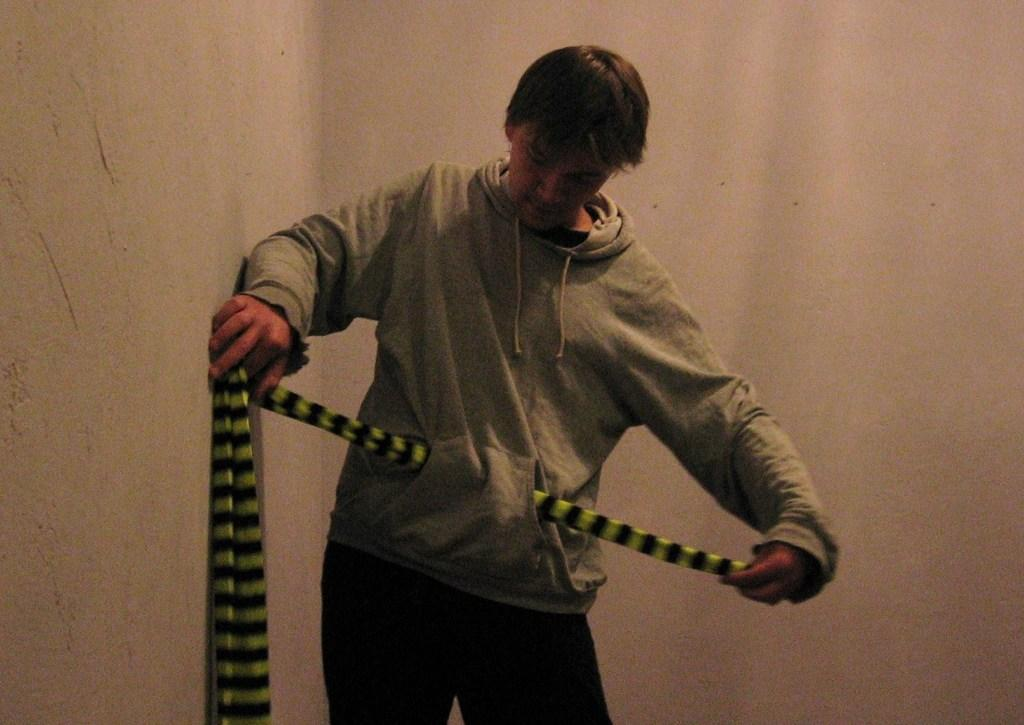What is the main subject of the image? There is a person in the image. What is the person holding in the image? The person is holding a scarf. What can be seen in the background of the image? There is a wall in the image. What type of stitch is being used to sew the doll in the image? There is no doll present in the image, so it is not possible to determine what type of stitch might be used. 